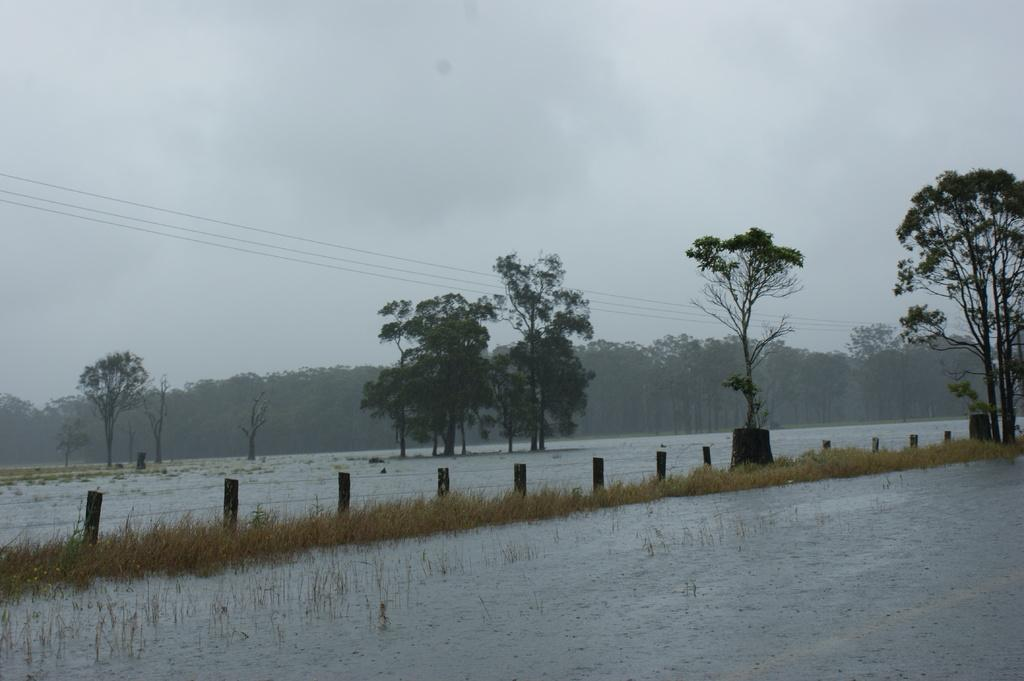What is the primary element in the image? The image consists of water. What type of vegetation can be seen at the bottom of the image? There is dry grass at the bottom of the image. What can be seen in the foreground of the image? There are many trees in the front of the image. How would you describe the sky in the image? The sky looks cloudy at the top of the image. How many screws can be seen holding the system together in the image? There are no screws or systems present in the image; it consists of water, dry grass, trees, and a cloudy sky. 